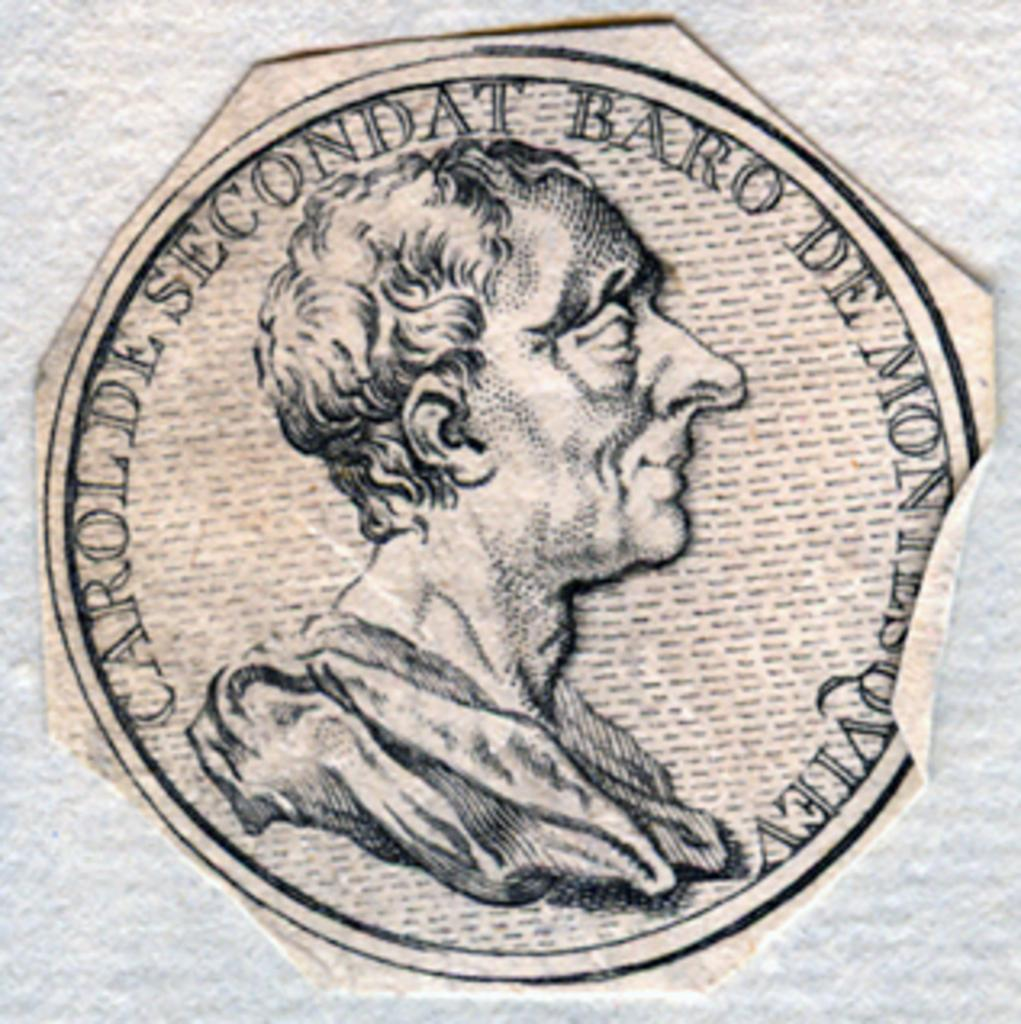What is shown on the piece of paper in the image? There is a person depicted on a piece of paper. What else can be seen on the paper besides the person? There is text on the paper. On what surface is the paper placed? The paper is placed on a white color surface. What type of twig is being used as a prop in the image? There is no twig present in the image. What joke is being told by the person depicted on the paper? The image does not depict a person telling a joke, nor is there any indication of a joke being told. 